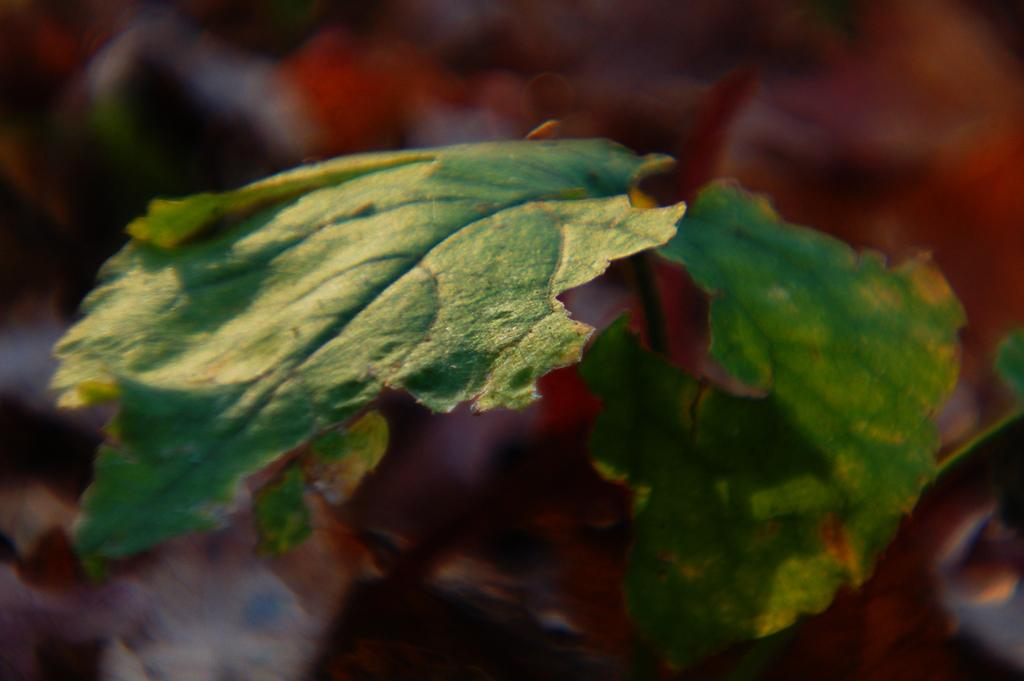How many leaves are visible in the image? There are two leaves in the image. What can be observed about each leaf in the image? Each leaf has a stem in the image. What type of body is depicted in the image? There is no body present in the image; it only features two leaves with stems. 